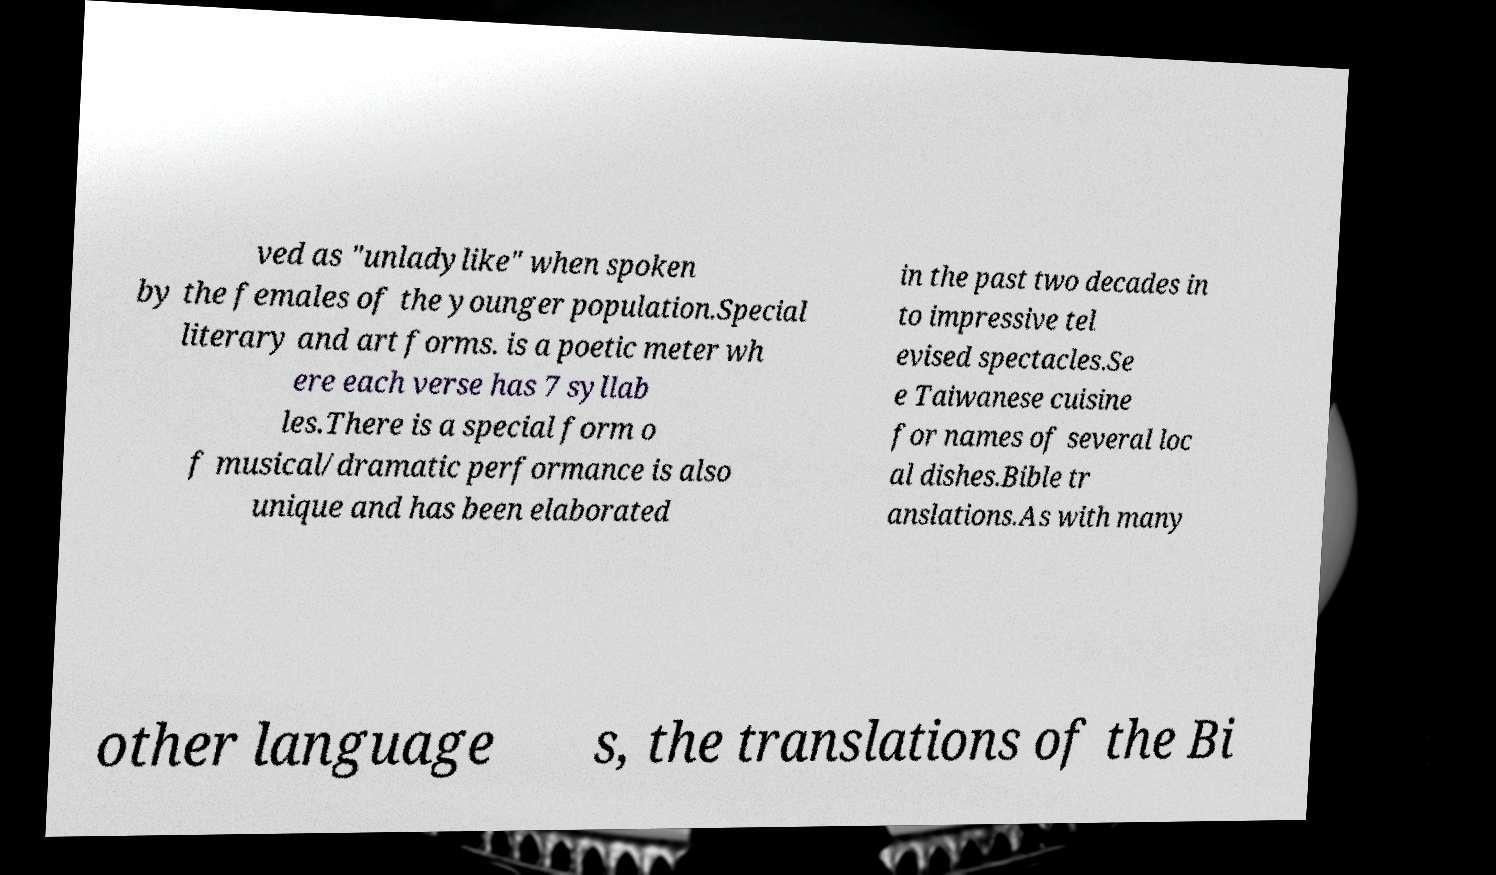Please identify and transcribe the text found in this image. ved as "unladylike" when spoken by the females of the younger population.Special literary and art forms. is a poetic meter wh ere each verse has 7 syllab les.There is a special form o f musical/dramatic performance is also unique and has been elaborated in the past two decades in to impressive tel evised spectacles.Se e Taiwanese cuisine for names of several loc al dishes.Bible tr anslations.As with many other language s, the translations of the Bi 